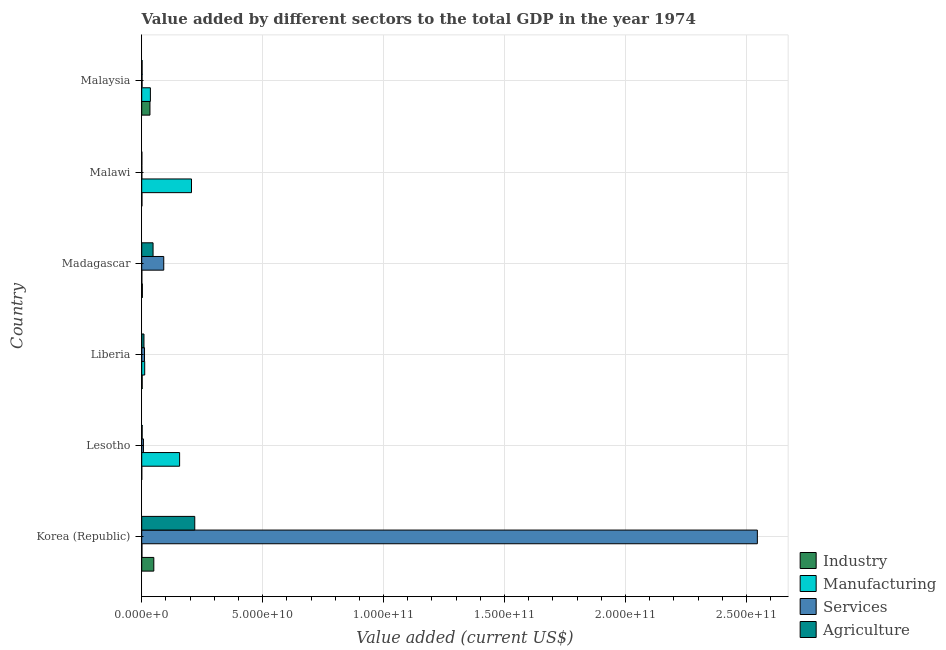How many different coloured bars are there?
Your response must be concise. 4. How many groups of bars are there?
Make the answer very short. 6. Are the number of bars per tick equal to the number of legend labels?
Make the answer very short. Yes. What is the label of the 3rd group of bars from the top?
Your answer should be very brief. Madagascar. In how many cases, is the number of bars for a given country not equal to the number of legend labels?
Make the answer very short. 0. What is the value added by agricultural sector in Korea (Republic)?
Keep it short and to the point. 2.19e+1. Across all countries, what is the maximum value added by manufacturing sector?
Your answer should be compact. 2.06e+1. Across all countries, what is the minimum value added by manufacturing sector?
Make the answer very short. 5.00e+07. In which country was the value added by manufacturing sector minimum?
Offer a very short reply. Madagascar. What is the total value added by services sector in the graph?
Offer a very short reply. 2.66e+11. What is the difference between the value added by industrial sector in Madagascar and that in Malawi?
Keep it short and to the point. 1.83e+08. What is the difference between the value added by agricultural sector in Madagascar and the value added by manufacturing sector in Liberia?
Provide a succinct answer. 3.46e+09. What is the average value added by manufacturing sector per country?
Ensure brevity in your answer.  6.86e+09. What is the difference between the value added by industrial sector and value added by manufacturing sector in Liberia?
Offer a terse response. -1.04e+09. In how many countries, is the value added by agricultural sector greater than 10000000000 US$?
Your response must be concise. 1. What is the ratio of the value added by services sector in Korea (Republic) to that in Malaysia?
Provide a succinct answer. 1817.52. Is the value added by agricultural sector in Korea (Republic) less than that in Malawi?
Provide a succinct answer. No. What is the difference between the highest and the second highest value added by services sector?
Ensure brevity in your answer.  2.45e+11. What is the difference between the highest and the lowest value added by services sector?
Your answer should be compact. 2.54e+11. Is the sum of the value added by agricultural sector in Malawi and Malaysia greater than the maximum value added by industrial sector across all countries?
Keep it short and to the point. No. Is it the case that in every country, the sum of the value added by agricultural sector and value added by services sector is greater than the sum of value added by manufacturing sector and value added by industrial sector?
Offer a very short reply. No. What does the 4th bar from the top in Madagascar represents?
Make the answer very short. Industry. What does the 1st bar from the bottom in Malaysia represents?
Your answer should be compact. Industry. Is it the case that in every country, the sum of the value added by industrial sector and value added by manufacturing sector is greater than the value added by services sector?
Your answer should be very brief. No. How many bars are there?
Offer a very short reply. 24. Are all the bars in the graph horizontal?
Provide a succinct answer. Yes. How many countries are there in the graph?
Give a very brief answer. 6. What is the difference between two consecutive major ticks on the X-axis?
Provide a short and direct response. 5.00e+1. Are the values on the major ticks of X-axis written in scientific E-notation?
Offer a very short reply. Yes. Does the graph contain grids?
Offer a terse response. Yes. Where does the legend appear in the graph?
Your answer should be compact. Bottom right. How many legend labels are there?
Your answer should be compact. 4. What is the title of the graph?
Provide a succinct answer. Value added by different sectors to the total GDP in the year 1974. What is the label or title of the X-axis?
Offer a very short reply. Value added (current US$). What is the label or title of the Y-axis?
Give a very brief answer. Country. What is the Value added (current US$) of Industry in Korea (Republic)?
Offer a very short reply. 5.00e+09. What is the Value added (current US$) in Manufacturing in Korea (Republic)?
Provide a succinct answer. 8.81e+07. What is the Value added (current US$) in Services in Korea (Republic)?
Your answer should be compact. 2.55e+11. What is the Value added (current US$) of Agriculture in Korea (Republic)?
Offer a very short reply. 2.19e+1. What is the Value added (current US$) in Industry in Lesotho?
Give a very brief answer. 1.89e+07. What is the Value added (current US$) of Manufacturing in Lesotho?
Provide a short and direct response. 1.57e+1. What is the Value added (current US$) in Services in Lesotho?
Your answer should be very brief. 7.07e+08. What is the Value added (current US$) of Agriculture in Lesotho?
Your response must be concise. 1.78e+08. What is the Value added (current US$) in Industry in Liberia?
Keep it short and to the point. 1.90e+08. What is the Value added (current US$) of Manufacturing in Liberia?
Keep it short and to the point. 1.23e+09. What is the Value added (current US$) in Services in Liberia?
Provide a short and direct response. 1.16e+09. What is the Value added (current US$) in Agriculture in Liberia?
Provide a succinct answer. 9.31e+08. What is the Value added (current US$) in Industry in Madagascar?
Offer a very short reply. 2.71e+08. What is the Value added (current US$) in Manufacturing in Madagascar?
Offer a very short reply. 5.00e+07. What is the Value added (current US$) in Services in Madagascar?
Offer a very short reply. 9.11e+09. What is the Value added (current US$) of Agriculture in Madagascar?
Give a very brief answer. 4.69e+09. What is the Value added (current US$) in Industry in Malawi?
Make the answer very short. 8.79e+07. What is the Value added (current US$) of Manufacturing in Malawi?
Provide a short and direct response. 2.06e+1. What is the Value added (current US$) in Services in Malawi?
Offer a terse response. 5.19e+07. What is the Value added (current US$) of Agriculture in Malawi?
Offer a very short reply. 5.94e+07. What is the Value added (current US$) of Industry in Malaysia?
Offer a terse response. 3.40e+09. What is the Value added (current US$) of Manufacturing in Malaysia?
Provide a succinct answer. 3.58e+09. What is the Value added (current US$) of Services in Malaysia?
Make the answer very short. 1.40e+08. What is the Value added (current US$) of Agriculture in Malaysia?
Your answer should be very brief. 1.57e+08. Across all countries, what is the maximum Value added (current US$) in Industry?
Ensure brevity in your answer.  5.00e+09. Across all countries, what is the maximum Value added (current US$) in Manufacturing?
Offer a terse response. 2.06e+1. Across all countries, what is the maximum Value added (current US$) in Services?
Your answer should be very brief. 2.55e+11. Across all countries, what is the maximum Value added (current US$) of Agriculture?
Provide a short and direct response. 2.19e+1. Across all countries, what is the minimum Value added (current US$) in Industry?
Make the answer very short. 1.89e+07. Across all countries, what is the minimum Value added (current US$) of Manufacturing?
Offer a terse response. 5.00e+07. Across all countries, what is the minimum Value added (current US$) of Services?
Give a very brief answer. 5.19e+07. Across all countries, what is the minimum Value added (current US$) of Agriculture?
Keep it short and to the point. 5.94e+07. What is the total Value added (current US$) of Industry in the graph?
Offer a terse response. 8.97e+09. What is the total Value added (current US$) in Manufacturing in the graph?
Provide a succinct answer. 4.12e+1. What is the total Value added (current US$) in Services in the graph?
Your response must be concise. 2.66e+11. What is the total Value added (current US$) of Agriculture in the graph?
Your answer should be very brief. 2.79e+1. What is the difference between the Value added (current US$) in Industry in Korea (Republic) and that in Lesotho?
Provide a short and direct response. 4.98e+09. What is the difference between the Value added (current US$) of Manufacturing in Korea (Republic) and that in Lesotho?
Your response must be concise. -1.56e+1. What is the difference between the Value added (current US$) in Services in Korea (Republic) and that in Lesotho?
Make the answer very short. 2.54e+11. What is the difference between the Value added (current US$) in Agriculture in Korea (Republic) and that in Lesotho?
Ensure brevity in your answer.  2.18e+1. What is the difference between the Value added (current US$) in Industry in Korea (Republic) and that in Liberia?
Provide a short and direct response. 4.81e+09. What is the difference between the Value added (current US$) in Manufacturing in Korea (Republic) and that in Liberia?
Ensure brevity in your answer.  -1.14e+09. What is the difference between the Value added (current US$) in Services in Korea (Republic) and that in Liberia?
Offer a very short reply. 2.53e+11. What is the difference between the Value added (current US$) of Agriculture in Korea (Republic) and that in Liberia?
Offer a very short reply. 2.10e+1. What is the difference between the Value added (current US$) in Industry in Korea (Republic) and that in Madagascar?
Provide a succinct answer. 4.73e+09. What is the difference between the Value added (current US$) in Manufacturing in Korea (Republic) and that in Madagascar?
Offer a terse response. 3.81e+07. What is the difference between the Value added (current US$) of Services in Korea (Republic) and that in Madagascar?
Offer a terse response. 2.45e+11. What is the difference between the Value added (current US$) in Agriculture in Korea (Republic) and that in Madagascar?
Your answer should be very brief. 1.72e+1. What is the difference between the Value added (current US$) in Industry in Korea (Republic) and that in Malawi?
Offer a very short reply. 4.91e+09. What is the difference between the Value added (current US$) in Manufacturing in Korea (Republic) and that in Malawi?
Keep it short and to the point. -2.05e+1. What is the difference between the Value added (current US$) of Services in Korea (Republic) and that in Malawi?
Your answer should be compact. 2.54e+11. What is the difference between the Value added (current US$) of Agriculture in Korea (Republic) and that in Malawi?
Provide a short and direct response. 2.19e+1. What is the difference between the Value added (current US$) in Industry in Korea (Republic) and that in Malaysia?
Make the answer very short. 1.59e+09. What is the difference between the Value added (current US$) of Manufacturing in Korea (Republic) and that in Malaysia?
Offer a very short reply. -3.49e+09. What is the difference between the Value added (current US$) in Services in Korea (Republic) and that in Malaysia?
Your answer should be very brief. 2.54e+11. What is the difference between the Value added (current US$) in Agriculture in Korea (Republic) and that in Malaysia?
Give a very brief answer. 2.18e+1. What is the difference between the Value added (current US$) in Industry in Lesotho and that in Liberia?
Offer a terse response. -1.71e+08. What is the difference between the Value added (current US$) in Manufacturing in Lesotho and that in Liberia?
Give a very brief answer. 1.44e+1. What is the difference between the Value added (current US$) of Services in Lesotho and that in Liberia?
Keep it short and to the point. -4.50e+08. What is the difference between the Value added (current US$) in Agriculture in Lesotho and that in Liberia?
Your response must be concise. -7.53e+08. What is the difference between the Value added (current US$) of Industry in Lesotho and that in Madagascar?
Ensure brevity in your answer.  -2.52e+08. What is the difference between the Value added (current US$) of Manufacturing in Lesotho and that in Madagascar?
Provide a succinct answer. 1.56e+1. What is the difference between the Value added (current US$) in Services in Lesotho and that in Madagascar?
Provide a short and direct response. -8.40e+09. What is the difference between the Value added (current US$) in Agriculture in Lesotho and that in Madagascar?
Your response must be concise. -4.51e+09. What is the difference between the Value added (current US$) in Industry in Lesotho and that in Malawi?
Provide a short and direct response. -6.90e+07. What is the difference between the Value added (current US$) of Manufacturing in Lesotho and that in Malawi?
Offer a very short reply. -4.91e+09. What is the difference between the Value added (current US$) of Services in Lesotho and that in Malawi?
Your answer should be very brief. 6.55e+08. What is the difference between the Value added (current US$) of Agriculture in Lesotho and that in Malawi?
Offer a terse response. 1.18e+08. What is the difference between the Value added (current US$) of Industry in Lesotho and that in Malaysia?
Your answer should be compact. -3.39e+09. What is the difference between the Value added (current US$) in Manufacturing in Lesotho and that in Malaysia?
Provide a succinct answer. 1.21e+1. What is the difference between the Value added (current US$) in Services in Lesotho and that in Malaysia?
Ensure brevity in your answer.  5.67e+08. What is the difference between the Value added (current US$) in Agriculture in Lesotho and that in Malaysia?
Provide a succinct answer. 2.04e+07. What is the difference between the Value added (current US$) of Industry in Liberia and that in Madagascar?
Your response must be concise. -8.16e+07. What is the difference between the Value added (current US$) of Manufacturing in Liberia and that in Madagascar?
Your answer should be compact. 1.18e+09. What is the difference between the Value added (current US$) of Services in Liberia and that in Madagascar?
Provide a succinct answer. -7.95e+09. What is the difference between the Value added (current US$) in Agriculture in Liberia and that in Madagascar?
Ensure brevity in your answer.  -3.76e+09. What is the difference between the Value added (current US$) in Industry in Liberia and that in Malawi?
Keep it short and to the point. 1.02e+08. What is the difference between the Value added (current US$) of Manufacturing in Liberia and that in Malawi?
Your answer should be compact. -1.93e+1. What is the difference between the Value added (current US$) of Services in Liberia and that in Malawi?
Keep it short and to the point. 1.10e+09. What is the difference between the Value added (current US$) in Agriculture in Liberia and that in Malawi?
Provide a short and direct response. 8.71e+08. What is the difference between the Value added (current US$) in Industry in Liberia and that in Malaysia?
Keep it short and to the point. -3.22e+09. What is the difference between the Value added (current US$) in Manufacturing in Liberia and that in Malaysia?
Give a very brief answer. -2.35e+09. What is the difference between the Value added (current US$) of Services in Liberia and that in Malaysia?
Provide a succinct answer. 1.02e+09. What is the difference between the Value added (current US$) in Agriculture in Liberia and that in Malaysia?
Your response must be concise. 7.73e+08. What is the difference between the Value added (current US$) of Industry in Madagascar and that in Malawi?
Provide a succinct answer. 1.83e+08. What is the difference between the Value added (current US$) of Manufacturing in Madagascar and that in Malawi?
Offer a terse response. -2.05e+1. What is the difference between the Value added (current US$) in Services in Madagascar and that in Malawi?
Your response must be concise. 9.06e+09. What is the difference between the Value added (current US$) of Agriculture in Madagascar and that in Malawi?
Provide a succinct answer. 4.63e+09. What is the difference between the Value added (current US$) of Industry in Madagascar and that in Malaysia?
Provide a short and direct response. -3.13e+09. What is the difference between the Value added (current US$) in Manufacturing in Madagascar and that in Malaysia?
Your answer should be compact. -3.53e+09. What is the difference between the Value added (current US$) of Services in Madagascar and that in Malaysia?
Provide a short and direct response. 8.97e+09. What is the difference between the Value added (current US$) of Agriculture in Madagascar and that in Malaysia?
Offer a very short reply. 4.53e+09. What is the difference between the Value added (current US$) in Industry in Malawi and that in Malaysia?
Provide a short and direct response. -3.32e+09. What is the difference between the Value added (current US$) of Manufacturing in Malawi and that in Malaysia?
Give a very brief answer. 1.70e+1. What is the difference between the Value added (current US$) in Services in Malawi and that in Malaysia?
Provide a short and direct response. -8.81e+07. What is the difference between the Value added (current US$) of Agriculture in Malawi and that in Malaysia?
Your response must be concise. -9.78e+07. What is the difference between the Value added (current US$) in Industry in Korea (Republic) and the Value added (current US$) in Manufacturing in Lesotho?
Your answer should be compact. -1.07e+1. What is the difference between the Value added (current US$) of Industry in Korea (Republic) and the Value added (current US$) of Services in Lesotho?
Your answer should be very brief. 4.29e+09. What is the difference between the Value added (current US$) in Industry in Korea (Republic) and the Value added (current US$) in Agriculture in Lesotho?
Keep it short and to the point. 4.82e+09. What is the difference between the Value added (current US$) in Manufacturing in Korea (Republic) and the Value added (current US$) in Services in Lesotho?
Provide a succinct answer. -6.19e+08. What is the difference between the Value added (current US$) of Manufacturing in Korea (Republic) and the Value added (current US$) of Agriculture in Lesotho?
Your answer should be compact. -8.95e+07. What is the difference between the Value added (current US$) in Services in Korea (Republic) and the Value added (current US$) in Agriculture in Lesotho?
Offer a very short reply. 2.54e+11. What is the difference between the Value added (current US$) of Industry in Korea (Republic) and the Value added (current US$) of Manufacturing in Liberia?
Make the answer very short. 3.77e+09. What is the difference between the Value added (current US$) of Industry in Korea (Republic) and the Value added (current US$) of Services in Liberia?
Your answer should be very brief. 3.84e+09. What is the difference between the Value added (current US$) in Industry in Korea (Republic) and the Value added (current US$) in Agriculture in Liberia?
Your answer should be compact. 4.07e+09. What is the difference between the Value added (current US$) in Manufacturing in Korea (Republic) and the Value added (current US$) in Services in Liberia?
Give a very brief answer. -1.07e+09. What is the difference between the Value added (current US$) of Manufacturing in Korea (Republic) and the Value added (current US$) of Agriculture in Liberia?
Give a very brief answer. -8.43e+08. What is the difference between the Value added (current US$) of Services in Korea (Republic) and the Value added (current US$) of Agriculture in Liberia?
Your answer should be very brief. 2.54e+11. What is the difference between the Value added (current US$) in Industry in Korea (Republic) and the Value added (current US$) in Manufacturing in Madagascar?
Make the answer very short. 4.95e+09. What is the difference between the Value added (current US$) in Industry in Korea (Republic) and the Value added (current US$) in Services in Madagascar?
Make the answer very short. -4.11e+09. What is the difference between the Value added (current US$) in Industry in Korea (Republic) and the Value added (current US$) in Agriculture in Madagascar?
Give a very brief answer. 3.12e+08. What is the difference between the Value added (current US$) of Manufacturing in Korea (Republic) and the Value added (current US$) of Services in Madagascar?
Your response must be concise. -9.02e+09. What is the difference between the Value added (current US$) in Manufacturing in Korea (Republic) and the Value added (current US$) in Agriculture in Madagascar?
Your answer should be very brief. -4.60e+09. What is the difference between the Value added (current US$) of Services in Korea (Republic) and the Value added (current US$) of Agriculture in Madagascar?
Provide a short and direct response. 2.50e+11. What is the difference between the Value added (current US$) of Industry in Korea (Republic) and the Value added (current US$) of Manufacturing in Malawi?
Give a very brief answer. -1.56e+1. What is the difference between the Value added (current US$) in Industry in Korea (Republic) and the Value added (current US$) in Services in Malawi?
Offer a very short reply. 4.95e+09. What is the difference between the Value added (current US$) in Industry in Korea (Republic) and the Value added (current US$) in Agriculture in Malawi?
Offer a very short reply. 4.94e+09. What is the difference between the Value added (current US$) of Manufacturing in Korea (Republic) and the Value added (current US$) of Services in Malawi?
Your response must be concise. 3.61e+07. What is the difference between the Value added (current US$) in Manufacturing in Korea (Republic) and the Value added (current US$) in Agriculture in Malawi?
Offer a very short reply. 2.87e+07. What is the difference between the Value added (current US$) of Services in Korea (Republic) and the Value added (current US$) of Agriculture in Malawi?
Make the answer very short. 2.54e+11. What is the difference between the Value added (current US$) in Industry in Korea (Republic) and the Value added (current US$) in Manufacturing in Malaysia?
Make the answer very short. 1.42e+09. What is the difference between the Value added (current US$) in Industry in Korea (Republic) and the Value added (current US$) in Services in Malaysia?
Your answer should be compact. 4.86e+09. What is the difference between the Value added (current US$) of Industry in Korea (Republic) and the Value added (current US$) of Agriculture in Malaysia?
Ensure brevity in your answer.  4.84e+09. What is the difference between the Value added (current US$) of Manufacturing in Korea (Republic) and the Value added (current US$) of Services in Malaysia?
Provide a short and direct response. -5.19e+07. What is the difference between the Value added (current US$) in Manufacturing in Korea (Republic) and the Value added (current US$) in Agriculture in Malaysia?
Give a very brief answer. -6.91e+07. What is the difference between the Value added (current US$) of Services in Korea (Republic) and the Value added (current US$) of Agriculture in Malaysia?
Provide a succinct answer. 2.54e+11. What is the difference between the Value added (current US$) of Industry in Lesotho and the Value added (current US$) of Manufacturing in Liberia?
Keep it short and to the point. -1.21e+09. What is the difference between the Value added (current US$) in Industry in Lesotho and the Value added (current US$) in Services in Liberia?
Your response must be concise. -1.14e+09. What is the difference between the Value added (current US$) of Industry in Lesotho and the Value added (current US$) of Agriculture in Liberia?
Your answer should be compact. -9.12e+08. What is the difference between the Value added (current US$) in Manufacturing in Lesotho and the Value added (current US$) in Services in Liberia?
Your answer should be very brief. 1.45e+1. What is the difference between the Value added (current US$) of Manufacturing in Lesotho and the Value added (current US$) of Agriculture in Liberia?
Keep it short and to the point. 1.47e+1. What is the difference between the Value added (current US$) of Services in Lesotho and the Value added (current US$) of Agriculture in Liberia?
Provide a short and direct response. -2.24e+08. What is the difference between the Value added (current US$) in Industry in Lesotho and the Value added (current US$) in Manufacturing in Madagascar?
Offer a terse response. -3.11e+07. What is the difference between the Value added (current US$) of Industry in Lesotho and the Value added (current US$) of Services in Madagascar?
Provide a succinct answer. -9.09e+09. What is the difference between the Value added (current US$) of Industry in Lesotho and the Value added (current US$) of Agriculture in Madagascar?
Your answer should be compact. -4.67e+09. What is the difference between the Value added (current US$) in Manufacturing in Lesotho and the Value added (current US$) in Services in Madagascar?
Provide a succinct answer. 6.55e+09. What is the difference between the Value added (current US$) in Manufacturing in Lesotho and the Value added (current US$) in Agriculture in Madagascar?
Make the answer very short. 1.10e+1. What is the difference between the Value added (current US$) in Services in Lesotho and the Value added (current US$) in Agriculture in Madagascar?
Provide a short and direct response. -3.98e+09. What is the difference between the Value added (current US$) of Industry in Lesotho and the Value added (current US$) of Manufacturing in Malawi?
Offer a terse response. -2.06e+1. What is the difference between the Value added (current US$) of Industry in Lesotho and the Value added (current US$) of Services in Malawi?
Offer a terse response. -3.31e+07. What is the difference between the Value added (current US$) of Industry in Lesotho and the Value added (current US$) of Agriculture in Malawi?
Ensure brevity in your answer.  -4.05e+07. What is the difference between the Value added (current US$) of Manufacturing in Lesotho and the Value added (current US$) of Services in Malawi?
Your response must be concise. 1.56e+1. What is the difference between the Value added (current US$) in Manufacturing in Lesotho and the Value added (current US$) in Agriculture in Malawi?
Provide a succinct answer. 1.56e+1. What is the difference between the Value added (current US$) of Services in Lesotho and the Value added (current US$) of Agriculture in Malawi?
Offer a very short reply. 6.47e+08. What is the difference between the Value added (current US$) in Industry in Lesotho and the Value added (current US$) in Manufacturing in Malaysia?
Ensure brevity in your answer.  -3.56e+09. What is the difference between the Value added (current US$) of Industry in Lesotho and the Value added (current US$) of Services in Malaysia?
Make the answer very short. -1.21e+08. What is the difference between the Value added (current US$) of Industry in Lesotho and the Value added (current US$) of Agriculture in Malaysia?
Provide a succinct answer. -1.38e+08. What is the difference between the Value added (current US$) in Manufacturing in Lesotho and the Value added (current US$) in Services in Malaysia?
Give a very brief answer. 1.55e+1. What is the difference between the Value added (current US$) in Manufacturing in Lesotho and the Value added (current US$) in Agriculture in Malaysia?
Offer a very short reply. 1.55e+1. What is the difference between the Value added (current US$) in Services in Lesotho and the Value added (current US$) in Agriculture in Malaysia?
Provide a short and direct response. 5.49e+08. What is the difference between the Value added (current US$) of Industry in Liberia and the Value added (current US$) of Manufacturing in Madagascar?
Your answer should be compact. 1.40e+08. What is the difference between the Value added (current US$) of Industry in Liberia and the Value added (current US$) of Services in Madagascar?
Your answer should be compact. -8.92e+09. What is the difference between the Value added (current US$) in Industry in Liberia and the Value added (current US$) in Agriculture in Madagascar?
Ensure brevity in your answer.  -4.50e+09. What is the difference between the Value added (current US$) of Manufacturing in Liberia and the Value added (current US$) of Services in Madagascar?
Ensure brevity in your answer.  -7.88e+09. What is the difference between the Value added (current US$) of Manufacturing in Liberia and the Value added (current US$) of Agriculture in Madagascar?
Make the answer very short. -3.46e+09. What is the difference between the Value added (current US$) in Services in Liberia and the Value added (current US$) in Agriculture in Madagascar?
Your answer should be compact. -3.53e+09. What is the difference between the Value added (current US$) of Industry in Liberia and the Value added (current US$) of Manufacturing in Malawi?
Offer a very short reply. -2.04e+1. What is the difference between the Value added (current US$) in Industry in Liberia and the Value added (current US$) in Services in Malawi?
Offer a terse response. 1.38e+08. What is the difference between the Value added (current US$) in Industry in Liberia and the Value added (current US$) in Agriculture in Malawi?
Make the answer very short. 1.30e+08. What is the difference between the Value added (current US$) of Manufacturing in Liberia and the Value added (current US$) of Services in Malawi?
Give a very brief answer. 1.18e+09. What is the difference between the Value added (current US$) of Manufacturing in Liberia and the Value added (current US$) of Agriculture in Malawi?
Provide a succinct answer. 1.17e+09. What is the difference between the Value added (current US$) of Services in Liberia and the Value added (current US$) of Agriculture in Malawi?
Your answer should be compact. 1.10e+09. What is the difference between the Value added (current US$) of Industry in Liberia and the Value added (current US$) of Manufacturing in Malaysia?
Your response must be concise. -3.39e+09. What is the difference between the Value added (current US$) of Industry in Liberia and the Value added (current US$) of Services in Malaysia?
Ensure brevity in your answer.  4.97e+07. What is the difference between the Value added (current US$) of Industry in Liberia and the Value added (current US$) of Agriculture in Malaysia?
Give a very brief answer. 3.25e+07. What is the difference between the Value added (current US$) of Manufacturing in Liberia and the Value added (current US$) of Services in Malaysia?
Give a very brief answer. 1.09e+09. What is the difference between the Value added (current US$) of Manufacturing in Liberia and the Value added (current US$) of Agriculture in Malaysia?
Provide a short and direct response. 1.07e+09. What is the difference between the Value added (current US$) in Services in Liberia and the Value added (current US$) in Agriculture in Malaysia?
Make the answer very short. 9.99e+08. What is the difference between the Value added (current US$) of Industry in Madagascar and the Value added (current US$) of Manufacturing in Malawi?
Your response must be concise. -2.03e+1. What is the difference between the Value added (current US$) in Industry in Madagascar and the Value added (current US$) in Services in Malawi?
Your answer should be compact. 2.19e+08. What is the difference between the Value added (current US$) in Industry in Madagascar and the Value added (current US$) in Agriculture in Malawi?
Your response must be concise. 2.12e+08. What is the difference between the Value added (current US$) in Manufacturing in Madagascar and the Value added (current US$) in Services in Malawi?
Give a very brief answer. -1.92e+06. What is the difference between the Value added (current US$) in Manufacturing in Madagascar and the Value added (current US$) in Agriculture in Malawi?
Provide a succinct answer. -9.41e+06. What is the difference between the Value added (current US$) of Services in Madagascar and the Value added (current US$) of Agriculture in Malawi?
Your answer should be very brief. 9.05e+09. What is the difference between the Value added (current US$) of Industry in Madagascar and the Value added (current US$) of Manufacturing in Malaysia?
Make the answer very short. -3.31e+09. What is the difference between the Value added (current US$) of Industry in Madagascar and the Value added (current US$) of Services in Malaysia?
Offer a very short reply. 1.31e+08. What is the difference between the Value added (current US$) in Industry in Madagascar and the Value added (current US$) in Agriculture in Malaysia?
Your answer should be very brief. 1.14e+08. What is the difference between the Value added (current US$) of Manufacturing in Madagascar and the Value added (current US$) of Services in Malaysia?
Your response must be concise. -9.00e+07. What is the difference between the Value added (current US$) of Manufacturing in Madagascar and the Value added (current US$) of Agriculture in Malaysia?
Offer a terse response. -1.07e+08. What is the difference between the Value added (current US$) of Services in Madagascar and the Value added (current US$) of Agriculture in Malaysia?
Provide a succinct answer. 8.95e+09. What is the difference between the Value added (current US$) in Industry in Malawi and the Value added (current US$) in Manufacturing in Malaysia?
Provide a short and direct response. -3.49e+09. What is the difference between the Value added (current US$) of Industry in Malawi and the Value added (current US$) of Services in Malaysia?
Your answer should be compact. -5.22e+07. What is the difference between the Value added (current US$) in Industry in Malawi and the Value added (current US$) in Agriculture in Malaysia?
Keep it short and to the point. -6.93e+07. What is the difference between the Value added (current US$) in Manufacturing in Malawi and the Value added (current US$) in Services in Malaysia?
Give a very brief answer. 2.04e+1. What is the difference between the Value added (current US$) in Manufacturing in Malawi and the Value added (current US$) in Agriculture in Malaysia?
Ensure brevity in your answer.  2.04e+1. What is the difference between the Value added (current US$) of Services in Malawi and the Value added (current US$) of Agriculture in Malaysia?
Give a very brief answer. -1.05e+08. What is the average Value added (current US$) of Industry per country?
Ensure brevity in your answer.  1.50e+09. What is the average Value added (current US$) in Manufacturing per country?
Keep it short and to the point. 6.86e+09. What is the average Value added (current US$) of Services per country?
Your response must be concise. 4.43e+1. What is the average Value added (current US$) of Agriculture per country?
Your response must be concise. 4.66e+09. What is the difference between the Value added (current US$) of Industry and Value added (current US$) of Manufacturing in Korea (Republic)?
Your response must be concise. 4.91e+09. What is the difference between the Value added (current US$) in Industry and Value added (current US$) in Services in Korea (Republic)?
Ensure brevity in your answer.  -2.50e+11. What is the difference between the Value added (current US$) in Industry and Value added (current US$) in Agriculture in Korea (Republic)?
Keep it short and to the point. -1.69e+1. What is the difference between the Value added (current US$) of Manufacturing and Value added (current US$) of Services in Korea (Republic)?
Provide a short and direct response. -2.54e+11. What is the difference between the Value added (current US$) of Manufacturing and Value added (current US$) of Agriculture in Korea (Republic)?
Make the answer very short. -2.18e+1. What is the difference between the Value added (current US$) of Services and Value added (current US$) of Agriculture in Korea (Republic)?
Offer a terse response. 2.33e+11. What is the difference between the Value added (current US$) in Industry and Value added (current US$) in Manufacturing in Lesotho?
Offer a terse response. -1.56e+1. What is the difference between the Value added (current US$) of Industry and Value added (current US$) of Services in Lesotho?
Offer a terse response. -6.88e+08. What is the difference between the Value added (current US$) of Industry and Value added (current US$) of Agriculture in Lesotho?
Ensure brevity in your answer.  -1.59e+08. What is the difference between the Value added (current US$) of Manufacturing and Value added (current US$) of Services in Lesotho?
Provide a succinct answer. 1.50e+1. What is the difference between the Value added (current US$) of Manufacturing and Value added (current US$) of Agriculture in Lesotho?
Your answer should be very brief. 1.55e+1. What is the difference between the Value added (current US$) in Services and Value added (current US$) in Agriculture in Lesotho?
Give a very brief answer. 5.29e+08. What is the difference between the Value added (current US$) of Industry and Value added (current US$) of Manufacturing in Liberia?
Your answer should be compact. -1.04e+09. What is the difference between the Value added (current US$) of Industry and Value added (current US$) of Services in Liberia?
Offer a very short reply. -9.66e+08. What is the difference between the Value added (current US$) in Industry and Value added (current US$) in Agriculture in Liberia?
Keep it short and to the point. -7.41e+08. What is the difference between the Value added (current US$) in Manufacturing and Value added (current US$) in Services in Liberia?
Keep it short and to the point. 7.29e+07. What is the difference between the Value added (current US$) in Manufacturing and Value added (current US$) in Agriculture in Liberia?
Your answer should be compact. 2.98e+08. What is the difference between the Value added (current US$) in Services and Value added (current US$) in Agriculture in Liberia?
Give a very brief answer. 2.26e+08. What is the difference between the Value added (current US$) of Industry and Value added (current US$) of Manufacturing in Madagascar?
Your response must be concise. 2.21e+08. What is the difference between the Value added (current US$) of Industry and Value added (current US$) of Services in Madagascar?
Keep it short and to the point. -8.84e+09. What is the difference between the Value added (current US$) of Industry and Value added (current US$) of Agriculture in Madagascar?
Provide a short and direct response. -4.41e+09. What is the difference between the Value added (current US$) of Manufacturing and Value added (current US$) of Services in Madagascar?
Your answer should be compact. -9.06e+09. What is the difference between the Value added (current US$) of Manufacturing and Value added (current US$) of Agriculture in Madagascar?
Make the answer very short. -4.64e+09. What is the difference between the Value added (current US$) of Services and Value added (current US$) of Agriculture in Madagascar?
Offer a terse response. 4.42e+09. What is the difference between the Value added (current US$) of Industry and Value added (current US$) of Manufacturing in Malawi?
Your answer should be compact. -2.05e+1. What is the difference between the Value added (current US$) of Industry and Value added (current US$) of Services in Malawi?
Keep it short and to the point. 3.59e+07. What is the difference between the Value added (current US$) of Industry and Value added (current US$) of Agriculture in Malawi?
Your answer should be compact. 2.84e+07. What is the difference between the Value added (current US$) of Manufacturing and Value added (current US$) of Services in Malawi?
Provide a short and direct response. 2.05e+1. What is the difference between the Value added (current US$) in Manufacturing and Value added (current US$) in Agriculture in Malawi?
Offer a terse response. 2.05e+1. What is the difference between the Value added (current US$) in Services and Value added (current US$) in Agriculture in Malawi?
Keep it short and to the point. -7.49e+06. What is the difference between the Value added (current US$) of Industry and Value added (current US$) of Manufacturing in Malaysia?
Offer a very short reply. -1.77e+08. What is the difference between the Value added (current US$) of Industry and Value added (current US$) of Services in Malaysia?
Your answer should be compact. 3.26e+09. What is the difference between the Value added (current US$) in Industry and Value added (current US$) in Agriculture in Malaysia?
Offer a terse response. 3.25e+09. What is the difference between the Value added (current US$) of Manufacturing and Value added (current US$) of Services in Malaysia?
Provide a succinct answer. 3.44e+09. What is the difference between the Value added (current US$) in Manufacturing and Value added (current US$) in Agriculture in Malaysia?
Your answer should be compact. 3.43e+09. What is the difference between the Value added (current US$) in Services and Value added (current US$) in Agriculture in Malaysia?
Make the answer very short. -1.72e+07. What is the ratio of the Value added (current US$) in Industry in Korea (Republic) to that in Lesotho?
Offer a terse response. 264.73. What is the ratio of the Value added (current US$) of Manufacturing in Korea (Republic) to that in Lesotho?
Your answer should be very brief. 0.01. What is the ratio of the Value added (current US$) in Services in Korea (Republic) to that in Lesotho?
Offer a very short reply. 360.18. What is the ratio of the Value added (current US$) of Agriculture in Korea (Republic) to that in Lesotho?
Keep it short and to the point. 123.49. What is the ratio of the Value added (current US$) of Industry in Korea (Republic) to that in Liberia?
Make the answer very short. 26.34. What is the ratio of the Value added (current US$) of Manufacturing in Korea (Republic) to that in Liberia?
Offer a terse response. 0.07. What is the ratio of the Value added (current US$) of Services in Korea (Republic) to that in Liberia?
Ensure brevity in your answer.  220.13. What is the ratio of the Value added (current US$) of Agriculture in Korea (Republic) to that in Liberia?
Your response must be concise. 23.57. What is the ratio of the Value added (current US$) in Industry in Korea (Republic) to that in Madagascar?
Provide a succinct answer. 18.42. What is the ratio of the Value added (current US$) in Manufacturing in Korea (Republic) to that in Madagascar?
Your response must be concise. 1.76. What is the ratio of the Value added (current US$) of Services in Korea (Republic) to that in Madagascar?
Your answer should be compact. 27.94. What is the ratio of the Value added (current US$) in Agriculture in Korea (Republic) to that in Madagascar?
Your answer should be compact. 4.68. What is the ratio of the Value added (current US$) in Industry in Korea (Republic) to that in Malawi?
Offer a terse response. 56.89. What is the ratio of the Value added (current US$) of Manufacturing in Korea (Republic) to that in Malawi?
Offer a terse response. 0. What is the ratio of the Value added (current US$) in Services in Korea (Republic) to that in Malawi?
Ensure brevity in your answer.  4900.08. What is the ratio of the Value added (current US$) of Agriculture in Korea (Republic) to that in Malawi?
Offer a terse response. 369.03. What is the ratio of the Value added (current US$) in Industry in Korea (Republic) to that in Malaysia?
Keep it short and to the point. 1.47. What is the ratio of the Value added (current US$) of Manufacturing in Korea (Republic) to that in Malaysia?
Offer a terse response. 0.02. What is the ratio of the Value added (current US$) of Services in Korea (Republic) to that in Malaysia?
Keep it short and to the point. 1817.52. What is the ratio of the Value added (current US$) in Agriculture in Korea (Republic) to that in Malaysia?
Make the answer very short. 139.51. What is the ratio of the Value added (current US$) in Industry in Lesotho to that in Liberia?
Offer a terse response. 0.1. What is the ratio of the Value added (current US$) of Manufacturing in Lesotho to that in Liberia?
Make the answer very short. 12.74. What is the ratio of the Value added (current US$) of Services in Lesotho to that in Liberia?
Your answer should be compact. 0.61. What is the ratio of the Value added (current US$) in Agriculture in Lesotho to that in Liberia?
Make the answer very short. 0.19. What is the ratio of the Value added (current US$) of Industry in Lesotho to that in Madagascar?
Ensure brevity in your answer.  0.07. What is the ratio of the Value added (current US$) in Manufacturing in Lesotho to that in Madagascar?
Keep it short and to the point. 313.14. What is the ratio of the Value added (current US$) of Services in Lesotho to that in Madagascar?
Ensure brevity in your answer.  0.08. What is the ratio of the Value added (current US$) in Agriculture in Lesotho to that in Madagascar?
Keep it short and to the point. 0.04. What is the ratio of the Value added (current US$) of Industry in Lesotho to that in Malawi?
Your answer should be very brief. 0.21. What is the ratio of the Value added (current US$) in Manufacturing in Lesotho to that in Malawi?
Your answer should be compact. 0.76. What is the ratio of the Value added (current US$) in Services in Lesotho to that in Malawi?
Your answer should be very brief. 13.6. What is the ratio of the Value added (current US$) in Agriculture in Lesotho to that in Malawi?
Your response must be concise. 2.99. What is the ratio of the Value added (current US$) in Industry in Lesotho to that in Malaysia?
Ensure brevity in your answer.  0.01. What is the ratio of the Value added (current US$) of Manufacturing in Lesotho to that in Malaysia?
Offer a terse response. 4.37. What is the ratio of the Value added (current US$) in Services in Lesotho to that in Malaysia?
Ensure brevity in your answer.  5.05. What is the ratio of the Value added (current US$) in Agriculture in Lesotho to that in Malaysia?
Your answer should be very brief. 1.13. What is the ratio of the Value added (current US$) of Industry in Liberia to that in Madagascar?
Provide a short and direct response. 0.7. What is the ratio of the Value added (current US$) of Manufacturing in Liberia to that in Madagascar?
Keep it short and to the point. 24.57. What is the ratio of the Value added (current US$) in Services in Liberia to that in Madagascar?
Provide a short and direct response. 0.13. What is the ratio of the Value added (current US$) of Agriculture in Liberia to that in Madagascar?
Your response must be concise. 0.2. What is the ratio of the Value added (current US$) in Industry in Liberia to that in Malawi?
Your answer should be very brief. 2.16. What is the ratio of the Value added (current US$) of Manufacturing in Liberia to that in Malawi?
Your answer should be compact. 0.06. What is the ratio of the Value added (current US$) of Services in Liberia to that in Malawi?
Your answer should be compact. 22.26. What is the ratio of the Value added (current US$) of Agriculture in Liberia to that in Malawi?
Offer a very short reply. 15.66. What is the ratio of the Value added (current US$) in Industry in Liberia to that in Malaysia?
Ensure brevity in your answer.  0.06. What is the ratio of the Value added (current US$) in Manufacturing in Liberia to that in Malaysia?
Your response must be concise. 0.34. What is the ratio of the Value added (current US$) in Services in Liberia to that in Malaysia?
Give a very brief answer. 8.26. What is the ratio of the Value added (current US$) in Agriculture in Liberia to that in Malaysia?
Your answer should be very brief. 5.92. What is the ratio of the Value added (current US$) in Industry in Madagascar to that in Malawi?
Offer a very short reply. 3.09. What is the ratio of the Value added (current US$) in Manufacturing in Madagascar to that in Malawi?
Your answer should be very brief. 0. What is the ratio of the Value added (current US$) of Services in Madagascar to that in Malawi?
Your answer should be compact. 175.38. What is the ratio of the Value added (current US$) in Agriculture in Madagascar to that in Malawi?
Provide a succinct answer. 78.85. What is the ratio of the Value added (current US$) in Industry in Madagascar to that in Malaysia?
Offer a very short reply. 0.08. What is the ratio of the Value added (current US$) in Manufacturing in Madagascar to that in Malaysia?
Your answer should be compact. 0.01. What is the ratio of the Value added (current US$) of Services in Madagascar to that in Malaysia?
Your answer should be very brief. 65.05. What is the ratio of the Value added (current US$) of Agriculture in Madagascar to that in Malaysia?
Keep it short and to the point. 29.81. What is the ratio of the Value added (current US$) in Industry in Malawi to that in Malaysia?
Your answer should be very brief. 0.03. What is the ratio of the Value added (current US$) in Manufacturing in Malawi to that in Malaysia?
Provide a short and direct response. 5.74. What is the ratio of the Value added (current US$) in Services in Malawi to that in Malaysia?
Your answer should be compact. 0.37. What is the ratio of the Value added (current US$) in Agriculture in Malawi to that in Malaysia?
Your response must be concise. 0.38. What is the difference between the highest and the second highest Value added (current US$) of Industry?
Your response must be concise. 1.59e+09. What is the difference between the highest and the second highest Value added (current US$) in Manufacturing?
Keep it short and to the point. 4.91e+09. What is the difference between the highest and the second highest Value added (current US$) in Services?
Your answer should be very brief. 2.45e+11. What is the difference between the highest and the second highest Value added (current US$) in Agriculture?
Provide a succinct answer. 1.72e+1. What is the difference between the highest and the lowest Value added (current US$) of Industry?
Provide a succinct answer. 4.98e+09. What is the difference between the highest and the lowest Value added (current US$) of Manufacturing?
Keep it short and to the point. 2.05e+1. What is the difference between the highest and the lowest Value added (current US$) of Services?
Keep it short and to the point. 2.54e+11. What is the difference between the highest and the lowest Value added (current US$) in Agriculture?
Your response must be concise. 2.19e+1. 